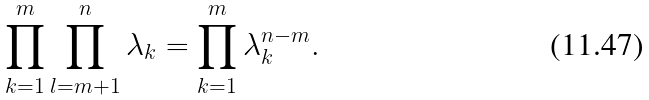<formula> <loc_0><loc_0><loc_500><loc_500>\prod _ { k = 1 } ^ { m } \prod _ { l = m + 1 } ^ { n } \lambda _ { k } = \prod _ { k = 1 } ^ { m } \lambda _ { k } ^ { n - m } .</formula> 